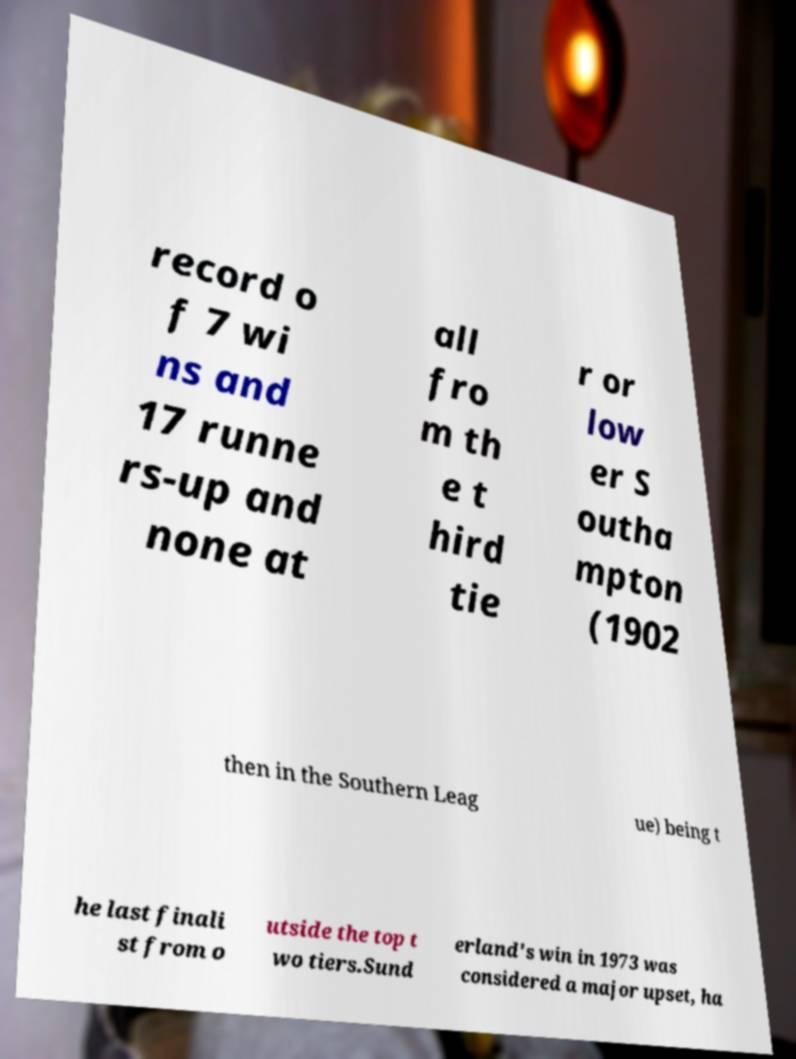Can you read and provide the text displayed in the image?This photo seems to have some interesting text. Can you extract and type it out for me? record o f 7 wi ns and 17 runne rs-up and none at all fro m th e t hird tie r or low er S outha mpton (1902 then in the Southern Leag ue) being t he last finali st from o utside the top t wo tiers.Sund erland's win in 1973 was considered a major upset, ha 